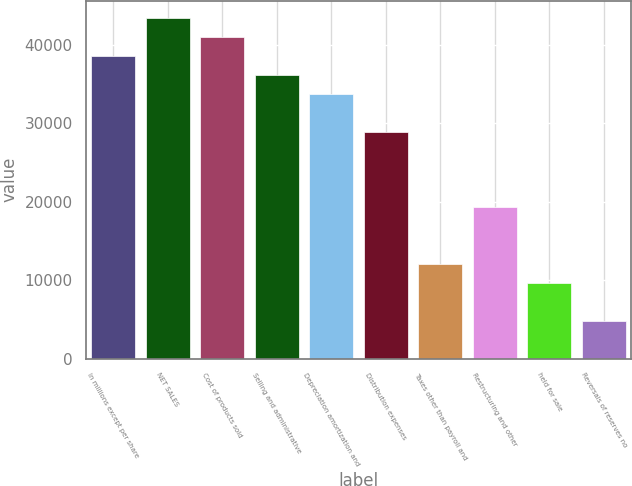Convert chart to OTSL. <chart><loc_0><loc_0><loc_500><loc_500><bar_chart><fcel>In millions except per share<fcel>NET SALES<fcel>Cost of products sold<fcel>Selling and administrative<fcel>Depreciation amortization and<fcel>Distribution expenses<fcel>Taxes other than payroll and<fcel>Restructuring and other<fcel>held for sale<fcel>Reversals of reserves no<nl><fcel>38554.1<fcel>43373.1<fcel>40963.6<fcel>36144.6<fcel>33735.1<fcel>28916<fcel>12049.4<fcel>19277.9<fcel>9639.85<fcel>4820.81<nl></chart> 